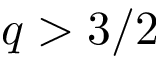Convert formula to latex. <formula><loc_0><loc_0><loc_500><loc_500>q > 3 / 2</formula> 